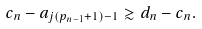Convert formula to latex. <formula><loc_0><loc_0><loc_500><loc_500>c _ { n } - a _ { j ( { p _ { n - 1 } + 1 } ) - 1 } \gtrsim d _ { n } - c _ { n } .</formula> 